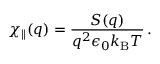<formula> <loc_0><loc_0><loc_500><loc_500>\chi _ { \| } ( q ) = \frac { S ( q ) } { q ^ { 2 } \epsilon _ { 0 } k _ { B } T } \, .</formula> 